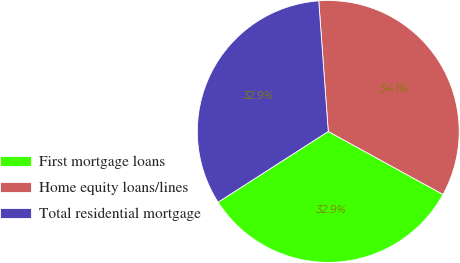<chart> <loc_0><loc_0><loc_500><loc_500><pie_chart><fcel>First mortgage loans<fcel>Home equity loans/lines<fcel>Total residential mortgage<nl><fcel>32.93%<fcel>34.15%<fcel>32.93%<nl></chart> 